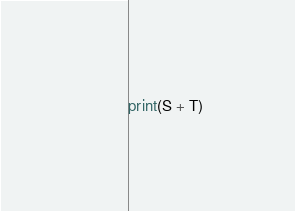<code> <loc_0><loc_0><loc_500><loc_500><_Python_>print(S + T)</code> 